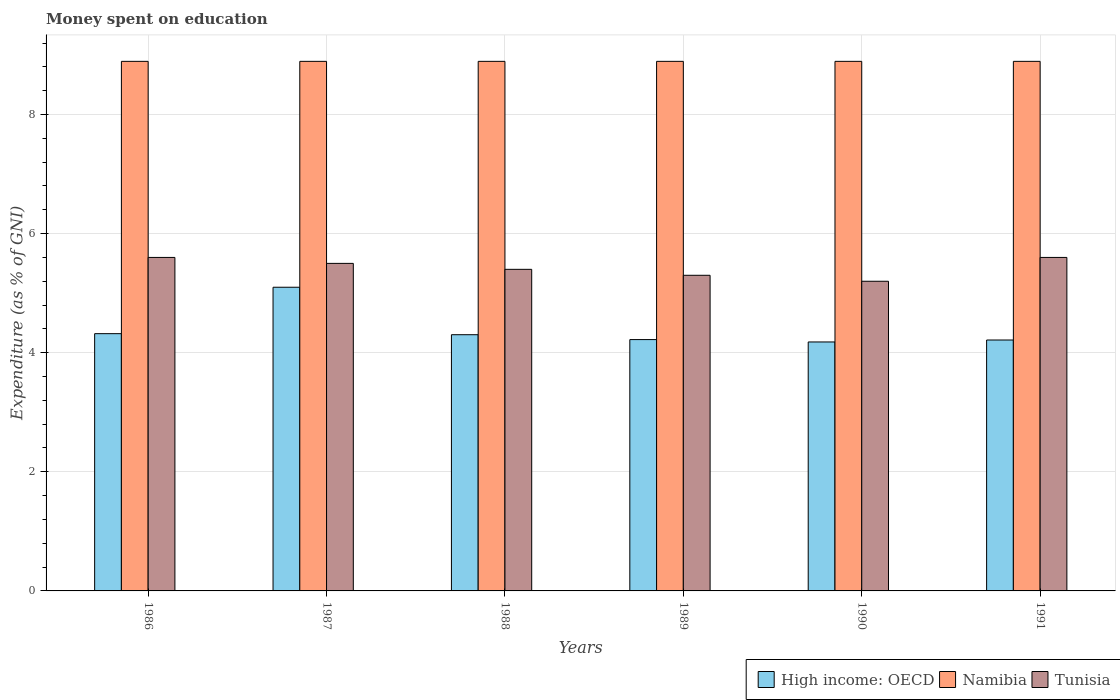How many groups of bars are there?
Your response must be concise. 6. Are the number of bars on each tick of the X-axis equal?
Offer a terse response. Yes. How many bars are there on the 6th tick from the left?
Give a very brief answer. 3. What is the label of the 1st group of bars from the left?
Your answer should be compact. 1986. What is the amount of money spent on education in Namibia in 1990?
Your answer should be very brief. 8.89. Across all years, what is the maximum amount of money spent on education in High income: OECD?
Ensure brevity in your answer.  5.1. Across all years, what is the minimum amount of money spent on education in High income: OECD?
Your answer should be compact. 4.18. What is the total amount of money spent on education in Namibia in the graph?
Your response must be concise. 53.36. What is the difference between the amount of money spent on education in Tunisia in 1986 and the amount of money spent on education in Namibia in 1991?
Your response must be concise. -3.29. What is the average amount of money spent on education in High income: OECD per year?
Provide a short and direct response. 4.39. In the year 1988, what is the difference between the amount of money spent on education in Tunisia and amount of money spent on education in High income: OECD?
Offer a terse response. 1.1. What is the ratio of the amount of money spent on education in High income: OECD in 1987 to that in 1989?
Provide a short and direct response. 1.21. Is the difference between the amount of money spent on education in Tunisia in 1986 and 1991 greater than the difference between the amount of money spent on education in High income: OECD in 1986 and 1991?
Provide a succinct answer. No. What is the difference between the highest and the second highest amount of money spent on education in Namibia?
Give a very brief answer. 0. Is the sum of the amount of money spent on education in Namibia in 1988 and 1989 greater than the maximum amount of money spent on education in High income: OECD across all years?
Your answer should be very brief. Yes. What does the 2nd bar from the left in 1986 represents?
Your answer should be compact. Namibia. What does the 2nd bar from the right in 1988 represents?
Your answer should be compact. Namibia. How many bars are there?
Keep it short and to the point. 18. Are all the bars in the graph horizontal?
Provide a succinct answer. No. How many years are there in the graph?
Make the answer very short. 6. What is the difference between two consecutive major ticks on the Y-axis?
Provide a succinct answer. 2. Are the values on the major ticks of Y-axis written in scientific E-notation?
Ensure brevity in your answer.  No. Does the graph contain grids?
Provide a short and direct response. Yes. Where does the legend appear in the graph?
Your answer should be compact. Bottom right. How many legend labels are there?
Offer a terse response. 3. What is the title of the graph?
Your answer should be very brief. Money spent on education. What is the label or title of the X-axis?
Keep it short and to the point. Years. What is the label or title of the Y-axis?
Your response must be concise. Expenditure (as % of GNI). What is the Expenditure (as % of GNI) in High income: OECD in 1986?
Provide a succinct answer. 4.32. What is the Expenditure (as % of GNI) of Namibia in 1986?
Provide a succinct answer. 8.89. What is the Expenditure (as % of GNI) of High income: OECD in 1987?
Your response must be concise. 5.1. What is the Expenditure (as % of GNI) in Namibia in 1987?
Your answer should be very brief. 8.89. What is the Expenditure (as % of GNI) of Tunisia in 1987?
Your response must be concise. 5.5. What is the Expenditure (as % of GNI) in High income: OECD in 1988?
Offer a very short reply. 4.3. What is the Expenditure (as % of GNI) in Namibia in 1988?
Your response must be concise. 8.89. What is the Expenditure (as % of GNI) of Tunisia in 1988?
Offer a terse response. 5.4. What is the Expenditure (as % of GNI) of High income: OECD in 1989?
Make the answer very short. 4.22. What is the Expenditure (as % of GNI) in Namibia in 1989?
Provide a short and direct response. 8.89. What is the Expenditure (as % of GNI) in Tunisia in 1989?
Offer a terse response. 5.3. What is the Expenditure (as % of GNI) in High income: OECD in 1990?
Give a very brief answer. 4.18. What is the Expenditure (as % of GNI) of Namibia in 1990?
Ensure brevity in your answer.  8.89. What is the Expenditure (as % of GNI) in Tunisia in 1990?
Ensure brevity in your answer.  5.2. What is the Expenditure (as % of GNI) of High income: OECD in 1991?
Offer a very short reply. 4.21. What is the Expenditure (as % of GNI) of Namibia in 1991?
Your response must be concise. 8.89. What is the Expenditure (as % of GNI) of Tunisia in 1991?
Keep it short and to the point. 5.6. Across all years, what is the maximum Expenditure (as % of GNI) in High income: OECD?
Make the answer very short. 5.1. Across all years, what is the maximum Expenditure (as % of GNI) of Namibia?
Provide a succinct answer. 8.89. Across all years, what is the maximum Expenditure (as % of GNI) of Tunisia?
Provide a short and direct response. 5.6. Across all years, what is the minimum Expenditure (as % of GNI) of High income: OECD?
Offer a terse response. 4.18. Across all years, what is the minimum Expenditure (as % of GNI) of Namibia?
Your response must be concise. 8.89. What is the total Expenditure (as % of GNI) of High income: OECD in the graph?
Make the answer very short. 26.34. What is the total Expenditure (as % of GNI) of Namibia in the graph?
Offer a very short reply. 53.35. What is the total Expenditure (as % of GNI) in Tunisia in the graph?
Your answer should be very brief. 32.6. What is the difference between the Expenditure (as % of GNI) in High income: OECD in 1986 and that in 1987?
Ensure brevity in your answer.  -0.78. What is the difference between the Expenditure (as % of GNI) of Namibia in 1986 and that in 1987?
Your answer should be very brief. 0. What is the difference between the Expenditure (as % of GNI) of High income: OECD in 1986 and that in 1988?
Your response must be concise. 0.02. What is the difference between the Expenditure (as % of GNI) in Namibia in 1986 and that in 1988?
Keep it short and to the point. 0. What is the difference between the Expenditure (as % of GNI) of High income: OECD in 1986 and that in 1989?
Provide a succinct answer. 0.1. What is the difference between the Expenditure (as % of GNI) in High income: OECD in 1986 and that in 1990?
Provide a short and direct response. 0.14. What is the difference between the Expenditure (as % of GNI) in Namibia in 1986 and that in 1990?
Provide a succinct answer. 0. What is the difference between the Expenditure (as % of GNI) in Tunisia in 1986 and that in 1990?
Keep it short and to the point. 0.4. What is the difference between the Expenditure (as % of GNI) in High income: OECD in 1986 and that in 1991?
Make the answer very short. 0.11. What is the difference between the Expenditure (as % of GNI) of High income: OECD in 1987 and that in 1988?
Offer a very short reply. 0.8. What is the difference between the Expenditure (as % of GNI) of Namibia in 1987 and that in 1988?
Provide a short and direct response. 0. What is the difference between the Expenditure (as % of GNI) of High income: OECD in 1987 and that in 1989?
Your answer should be compact. 0.88. What is the difference between the Expenditure (as % of GNI) in High income: OECD in 1987 and that in 1990?
Give a very brief answer. 0.92. What is the difference between the Expenditure (as % of GNI) in Tunisia in 1987 and that in 1990?
Provide a succinct answer. 0.3. What is the difference between the Expenditure (as % of GNI) of High income: OECD in 1987 and that in 1991?
Offer a very short reply. 0.89. What is the difference between the Expenditure (as % of GNI) of Tunisia in 1987 and that in 1991?
Give a very brief answer. -0.1. What is the difference between the Expenditure (as % of GNI) in High income: OECD in 1988 and that in 1989?
Provide a succinct answer. 0.08. What is the difference between the Expenditure (as % of GNI) of Namibia in 1988 and that in 1989?
Provide a short and direct response. 0. What is the difference between the Expenditure (as % of GNI) in High income: OECD in 1988 and that in 1990?
Give a very brief answer. 0.12. What is the difference between the Expenditure (as % of GNI) in Namibia in 1988 and that in 1990?
Give a very brief answer. 0. What is the difference between the Expenditure (as % of GNI) in High income: OECD in 1988 and that in 1991?
Offer a terse response. 0.09. What is the difference between the Expenditure (as % of GNI) of Tunisia in 1988 and that in 1991?
Ensure brevity in your answer.  -0.2. What is the difference between the Expenditure (as % of GNI) of High income: OECD in 1989 and that in 1991?
Give a very brief answer. 0.01. What is the difference between the Expenditure (as % of GNI) in Namibia in 1989 and that in 1991?
Ensure brevity in your answer.  0. What is the difference between the Expenditure (as % of GNI) of High income: OECD in 1990 and that in 1991?
Your response must be concise. -0.03. What is the difference between the Expenditure (as % of GNI) in Tunisia in 1990 and that in 1991?
Make the answer very short. -0.4. What is the difference between the Expenditure (as % of GNI) of High income: OECD in 1986 and the Expenditure (as % of GNI) of Namibia in 1987?
Your response must be concise. -4.57. What is the difference between the Expenditure (as % of GNI) in High income: OECD in 1986 and the Expenditure (as % of GNI) in Tunisia in 1987?
Your response must be concise. -1.18. What is the difference between the Expenditure (as % of GNI) of Namibia in 1986 and the Expenditure (as % of GNI) of Tunisia in 1987?
Your answer should be very brief. 3.39. What is the difference between the Expenditure (as % of GNI) of High income: OECD in 1986 and the Expenditure (as % of GNI) of Namibia in 1988?
Keep it short and to the point. -4.57. What is the difference between the Expenditure (as % of GNI) in High income: OECD in 1986 and the Expenditure (as % of GNI) in Tunisia in 1988?
Keep it short and to the point. -1.08. What is the difference between the Expenditure (as % of GNI) in Namibia in 1986 and the Expenditure (as % of GNI) in Tunisia in 1988?
Provide a succinct answer. 3.49. What is the difference between the Expenditure (as % of GNI) in High income: OECD in 1986 and the Expenditure (as % of GNI) in Namibia in 1989?
Your answer should be compact. -4.57. What is the difference between the Expenditure (as % of GNI) in High income: OECD in 1986 and the Expenditure (as % of GNI) in Tunisia in 1989?
Offer a terse response. -0.98. What is the difference between the Expenditure (as % of GNI) in Namibia in 1986 and the Expenditure (as % of GNI) in Tunisia in 1989?
Your answer should be very brief. 3.59. What is the difference between the Expenditure (as % of GNI) in High income: OECD in 1986 and the Expenditure (as % of GNI) in Namibia in 1990?
Make the answer very short. -4.57. What is the difference between the Expenditure (as % of GNI) of High income: OECD in 1986 and the Expenditure (as % of GNI) of Tunisia in 1990?
Give a very brief answer. -0.88. What is the difference between the Expenditure (as % of GNI) of Namibia in 1986 and the Expenditure (as % of GNI) of Tunisia in 1990?
Your response must be concise. 3.69. What is the difference between the Expenditure (as % of GNI) of High income: OECD in 1986 and the Expenditure (as % of GNI) of Namibia in 1991?
Your answer should be compact. -4.57. What is the difference between the Expenditure (as % of GNI) of High income: OECD in 1986 and the Expenditure (as % of GNI) of Tunisia in 1991?
Your answer should be very brief. -1.28. What is the difference between the Expenditure (as % of GNI) in Namibia in 1986 and the Expenditure (as % of GNI) in Tunisia in 1991?
Provide a succinct answer. 3.29. What is the difference between the Expenditure (as % of GNI) of High income: OECD in 1987 and the Expenditure (as % of GNI) of Namibia in 1988?
Offer a very short reply. -3.79. What is the difference between the Expenditure (as % of GNI) in High income: OECD in 1987 and the Expenditure (as % of GNI) in Tunisia in 1988?
Your answer should be very brief. -0.3. What is the difference between the Expenditure (as % of GNI) in Namibia in 1987 and the Expenditure (as % of GNI) in Tunisia in 1988?
Provide a succinct answer. 3.49. What is the difference between the Expenditure (as % of GNI) of High income: OECD in 1987 and the Expenditure (as % of GNI) of Namibia in 1989?
Your answer should be compact. -3.79. What is the difference between the Expenditure (as % of GNI) of High income: OECD in 1987 and the Expenditure (as % of GNI) of Tunisia in 1989?
Give a very brief answer. -0.2. What is the difference between the Expenditure (as % of GNI) of Namibia in 1987 and the Expenditure (as % of GNI) of Tunisia in 1989?
Provide a short and direct response. 3.59. What is the difference between the Expenditure (as % of GNI) of High income: OECD in 1987 and the Expenditure (as % of GNI) of Namibia in 1990?
Ensure brevity in your answer.  -3.79. What is the difference between the Expenditure (as % of GNI) in High income: OECD in 1987 and the Expenditure (as % of GNI) in Tunisia in 1990?
Provide a succinct answer. -0.1. What is the difference between the Expenditure (as % of GNI) in Namibia in 1987 and the Expenditure (as % of GNI) in Tunisia in 1990?
Your answer should be compact. 3.69. What is the difference between the Expenditure (as % of GNI) of High income: OECD in 1987 and the Expenditure (as % of GNI) of Namibia in 1991?
Provide a short and direct response. -3.79. What is the difference between the Expenditure (as % of GNI) in High income: OECD in 1987 and the Expenditure (as % of GNI) in Tunisia in 1991?
Give a very brief answer. -0.5. What is the difference between the Expenditure (as % of GNI) of Namibia in 1987 and the Expenditure (as % of GNI) of Tunisia in 1991?
Make the answer very short. 3.29. What is the difference between the Expenditure (as % of GNI) of High income: OECD in 1988 and the Expenditure (as % of GNI) of Namibia in 1989?
Keep it short and to the point. -4.59. What is the difference between the Expenditure (as % of GNI) of High income: OECD in 1988 and the Expenditure (as % of GNI) of Tunisia in 1989?
Ensure brevity in your answer.  -1. What is the difference between the Expenditure (as % of GNI) of Namibia in 1988 and the Expenditure (as % of GNI) of Tunisia in 1989?
Offer a very short reply. 3.59. What is the difference between the Expenditure (as % of GNI) in High income: OECD in 1988 and the Expenditure (as % of GNI) in Namibia in 1990?
Ensure brevity in your answer.  -4.59. What is the difference between the Expenditure (as % of GNI) of High income: OECD in 1988 and the Expenditure (as % of GNI) of Tunisia in 1990?
Ensure brevity in your answer.  -0.9. What is the difference between the Expenditure (as % of GNI) in Namibia in 1988 and the Expenditure (as % of GNI) in Tunisia in 1990?
Offer a very short reply. 3.69. What is the difference between the Expenditure (as % of GNI) in High income: OECD in 1988 and the Expenditure (as % of GNI) in Namibia in 1991?
Your response must be concise. -4.59. What is the difference between the Expenditure (as % of GNI) of High income: OECD in 1988 and the Expenditure (as % of GNI) of Tunisia in 1991?
Offer a very short reply. -1.3. What is the difference between the Expenditure (as % of GNI) of Namibia in 1988 and the Expenditure (as % of GNI) of Tunisia in 1991?
Offer a very short reply. 3.29. What is the difference between the Expenditure (as % of GNI) of High income: OECD in 1989 and the Expenditure (as % of GNI) of Namibia in 1990?
Your answer should be very brief. -4.67. What is the difference between the Expenditure (as % of GNI) in High income: OECD in 1989 and the Expenditure (as % of GNI) in Tunisia in 1990?
Keep it short and to the point. -0.98. What is the difference between the Expenditure (as % of GNI) in Namibia in 1989 and the Expenditure (as % of GNI) in Tunisia in 1990?
Keep it short and to the point. 3.69. What is the difference between the Expenditure (as % of GNI) in High income: OECD in 1989 and the Expenditure (as % of GNI) in Namibia in 1991?
Provide a succinct answer. -4.67. What is the difference between the Expenditure (as % of GNI) of High income: OECD in 1989 and the Expenditure (as % of GNI) of Tunisia in 1991?
Offer a terse response. -1.38. What is the difference between the Expenditure (as % of GNI) in Namibia in 1989 and the Expenditure (as % of GNI) in Tunisia in 1991?
Keep it short and to the point. 3.29. What is the difference between the Expenditure (as % of GNI) in High income: OECD in 1990 and the Expenditure (as % of GNI) in Namibia in 1991?
Keep it short and to the point. -4.71. What is the difference between the Expenditure (as % of GNI) in High income: OECD in 1990 and the Expenditure (as % of GNI) in Tunisia in 1991?
Make the answer very short. -1.42. What is the difference between the Expenditure (as % of GNI) in Namibia in 1990 and the Expenditure (as % of GNI) in Tunisia in 1991?
Make the answer very short. 3.29. What is the average Expenditure (as % of GNI) of High income: OECD per year?
Provide a succinct answer. 4.39. What is the average Expenditure (as % of GNI) in Namibia per year?
Provide a succinct answer. 8.89. What is the average Expenditure (as % of GNI) of Tunisia per year?
Your response must be concise. 5.43. In the year 1986, what is the difference between the Expenditure (as % of GNI) of High income: OECD and Expenditure (as % of GNI) of Namibia?
Keep it short and to the point. -4.57. In the year 1986, what is the difference between the Expenditure (as % of GNI) in High income: OECD and Expenditure (as % of GNI) in Tunisia?
Give a very brief answer. -1.28. In the year 1986, what is the difference between the Expenditure (as % of GNI) in Namibia and Expenditure (as % of GNI) in Tunisia?
Provide a succinct answer. 3.29. In the year 1987, what is the difference between the Expenditure (as % of GNI) in High income: OECD and Expenditure (as % of GNI) in Namibia?
Your response must be concise. -3.79. In the year 1987, what is the difference between the Expenditure (as % of GNI) in High income: OECD and Expenditure (as % of GNI) in Tunisia?
Offer a very short reply. -0.4. In the year 1987, what is the difference between the Expenditure (as % of GNI) in Namibia and Expenditure (as % of GNI) in Tunisia?
Offer a very short reply. 3.39. In the year 1988, what is the difference between the Expenditure (as % of GNI) in High income: OECD and Expenditure (as % of GNI) in Namibia?
Ensure brevity in your answer.  -4.59. In the year 1988, what is the difference between the Expenditure (as % of GNI) in High income: OECD and Expenditure (as % of GNI) in Tunisia?
Provide a short and direct response. -1.1. In the year 1988, what is the difference between the Expenditure (as % of GNI) of Namibia and Expenditure (as % of GNI) of Tunisia?
Ensure brevity in your answer.  3.49. In the year 1989, what is the difference between the Expenditure (as % of GNI) in High income: OECD and Expenditure (as % of GNI) in Namibia?
Provide a short and direct response. -4.67. In the year 1989, what is the difference between the Expenditure (as % of GNI) in High income: OECD and Expenditure (as % of GNI) in Tunisia?
Provide a short and direct response. -1.08. In the year 1989, what is the difference between the Expenditure (as % of GNI) of Namibia and Expenditure (as % of GNI) of Tunisia?
Your answer should be very brief. 3.59. In the year 1990, what is the difference between the Expenditure (as % of GNI) in High income: OECD and Expenditure (as % of GNI) in Namibia?
Your response must be concise. -4.71. In the year 1990, what is the difference between the Expenditure (as % of GNI) in High income: OECD and Expenditure (as % of GNI) in Tunisia?
Provide a succinct answer. -1.02. In the year 1990, what is the difference between the Expenditure (as % of GNI) in Namibia and Expenditure (as % of GNI) in Tunisia?
Offer a very short reply. 3.69. In the year 1991, what is the difference between the Expenditure (as % of GNI) of High income: OECD and Expenditure (as % of GNI) of Namibia?
Give a very brief answer. -4.68. In the year 1991, what is the difference between the Expenditure (as % of GNI) in High income: OECD and Expenditure (as % of GNI) in Tunisia?
Make the answer very short. -1.39. In the year 1991, what is the difference between the Expenditure (as % of GNI) in Namibia and Expenditure (as % of GNI) in Tunisia?
Your answer should be very brief. 3.29. What is the ratio of the Expenditure (as % of GNI) in High income: OECD in 1986 to that in 1987?
Offer a terse response. 0.85. What is the ratio of the Expenditure (as % of GNI) in Tunisia in 1986 to that in 1987?
Your answer should be compact. 1.02. What is the ratio of the Expenditure (as % of GNI) of Namibia in 1986 to that in 1988?
Your answer should be very brief. 1. What is the ratio of the Expenditure (as % of GNI) in Tunisia in 1986 to that in 1988?
Keep it short and to the point. 1.04. What is the ratio of the Expenditure (as % of GNI) in High income: OECD in 1986 to that in 1989?
Ensure brevity in your answer.  1.02. What is the ratio of the Expenditure (as % of GNI) in Namibia in 1986 to that in 1989?
Keep it short and to the point. 1. What is the ratio of the Expenditure (as % of GNI) in Tunisia in 1986 to that in 1989?
Provide a succinct answer. 1.06. What is the ratio of the Expenditure (as % of GNI) of Namibia in 1986 to that in 1990?
Your answer should be compact. 1. What is the ratio of the Expenditure (as % of GNI) in Tunisia in 1986 to that in 1990?
Your answer should be compact. 1.08. What is the ratio of the Expenditure (as % of GNI) in High income: OECD in 1986 to that in 1991?
Offer a very short reply. 1.03. What is the ratio of the Expenditure (as % of GNI) in Namibia in 1986 to that in 1991?
Your answer should be very brief. 1. What is the ratio of the Expenditure (as % of GNI) of Tunisia in 1986 to that in 1991?
Give a very brief answer. 1. What is the ratio of the Expenditure (as % of GNI) in High income: OECD in 1987 to that in 1988?
Offer a very short reply. 1.19. What is the ratio of the Expenditure (as % of GNI) of Namibia in 1987 to that in 1988?
Keep it short and to the point. 1. What is the ratio of the Expenditure (as % of GNI) of Tunisia in 1987 to that in 1988?
Make the answer very short. 1.02. What is the ratio of the Expenditure (as % of GNI) of High income: OECD in 1987 to that in 1989?
Make the answer very short. 1.21. What is the ratio of the Expenditure (as % of GNI) of Namibia in 1987 to that in 1989?
Your response must be concise. 1. What is the ratio of the Expenditure (as % of GNI) of Tunisia in 1987 to that in 1989?
Provide a short and direct response. 1.04. What is the ratio of the Expenditure (as % of GNI) of High income: OECD in 1987 to that in 1990?
Provide a succinct answer. 1.22. What is the ratio of the Expenditure (as % of GNI) in Tunisia in 1987 to that in 1990?
Your response must be concise. 1.06. What is the ratio of the Expenditure (as % of GNI) of High income: OECD in 1987 to that in 1991?
Make the answer very short. 1.21. What is the ratio of the Expenditure (as % of GNI) in Namibia in 1987 to that in 1991?
Provide a succinct answer. 1. What is the ratio of the Expenditure (as % of GNI) in Tunisia in 1987 to that in 1991?
Make the answer very short. 0.98. What is the ratio of the Expenditure (as % of GNI) in High income: OECD in 1988 to that in 1989?
Provide a succinct answer. 1.02. What is the ratio of the Expenditure (as % of GNI) of Namibia in 1988 to that in 1989?
Give a very brief answer. 1. What is the ratio of the Expenditure (as % of GNI) of Tunisia in 1988 to that in 1989?
Your response must be concise. 1.02. What is the ratio of the Expenditure (as % of GNI) of High income: OECD in 1988 to that in 1990?
Provide a short and direct response. 1.03. What is the ratio of the Expenditure (as % of GNI) in Tunisia in 1988 to that in 1990?
Make the answer very short. 1.04. What is the ratio of the Expenditure (as % of GNI) in High income: OECD in 1988 to that in 1991?
Provide a succinct answer. 1.02. What is the ratio of the Expenditure (as % of GNI) in Namibia in 1988 to that in 1991?
Provide a short and direct response. 1. What is the ratio of the Expenditure (as % of GNI) in Tunisia in 1988 to that in 1991?
Provide a short and direct response. 0.96. What is the ratio of the Expenditure (as % of GNI) in High income: OECD in 1989 to that in 1990?
Keep it short and to the point. 1.01. What is the ratio of the Expenditure (as % of GNI) of Tunisia in 1989 to that in 1990?
Ensure brevity in your answer.  1.02. What is the ratio of the Expenditure (as % of GNI) of Namibia in 1989 to that in 1991?
Make the answer very short. 1. What is the ratio of the Expenditure (as % of GNI) of Tunisia in 1989 to that in 1991?
Offer a terse response. 0.95. What is the ratio of the Expenditure (as % of GNI) in High income: OECD in 1990 to that in 1991?
Ensure brevity in your answer.  0.99. What is the ratio of the Expenditure (as % of GNI) of Namibia in 1990 to that in 1991?
Offer a terse response. 1. What is the ratio of the Expenditure (as % of GNI) in Tunisia in 1990 to that in 1991?
Your answer should be very brief. 0.93. What is the difference between the highest and the second highest Expenditure (as % of GNI) of High income: OECD?
Your answer should be compact. 0.78. What is the difference between the highest and the lowest Expenditure (as % of GNI) in High income: OECD?
Offer a terse response. 0.92. 